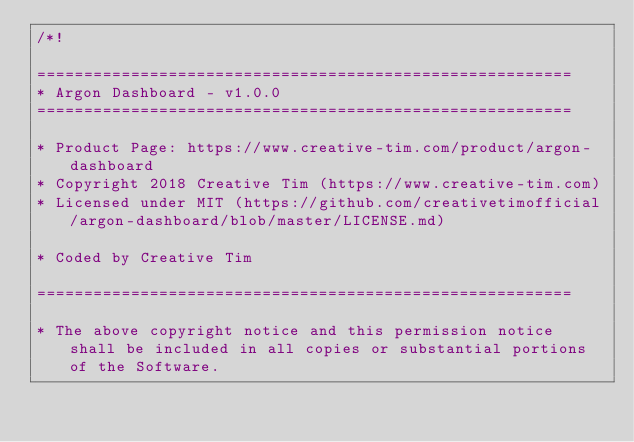<code> <loc_0><loc_0><loc_500><loc_500><_CSS_>/*!

=========================================================
* Argon Dashboard - v1.0.0
=========================================================

* Product Page: https://www.creative-tim.com/product/argon-dashboard
* Copyright 2018 Creative Tim (https://www.creative-tim.com)
* Licensed under MIT (https://github.com/creativetimofficial/argon-dashboard/blob/master/LICENSE.md)

* Coded by Creative Tim

=========================================================

* The above copyright notice and this permission notice shall be included in all copies or substantial portions of the Software.
</code> 